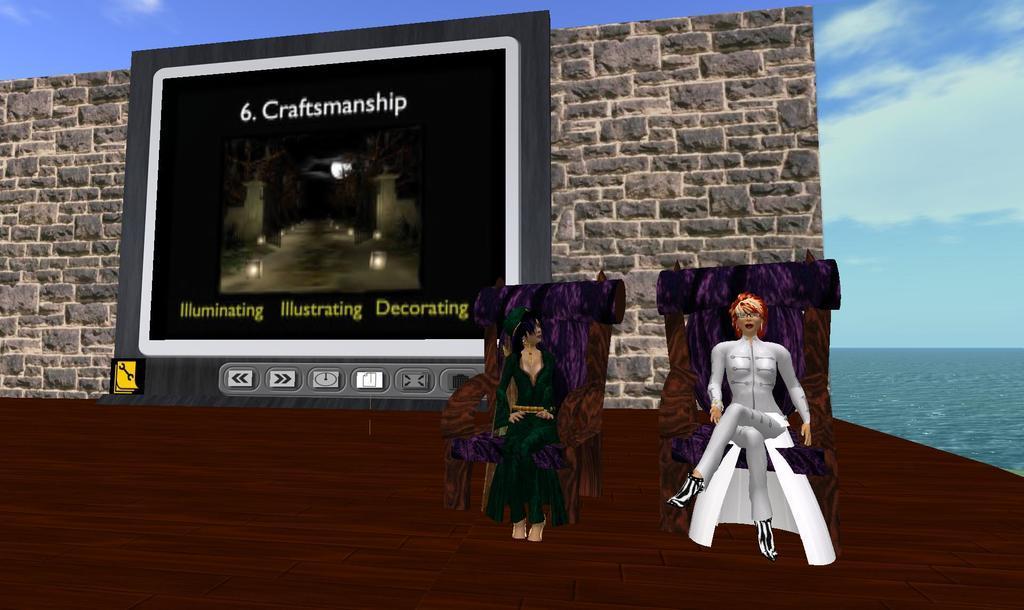Describe this image in one or two sentences. It is a graphical image, in the image we can see two persons sitting. Behind them there is wall, on the wall there is a screen. Behind the wall there are some clouds in the sky. In the bottom right corner of the image there is water. 